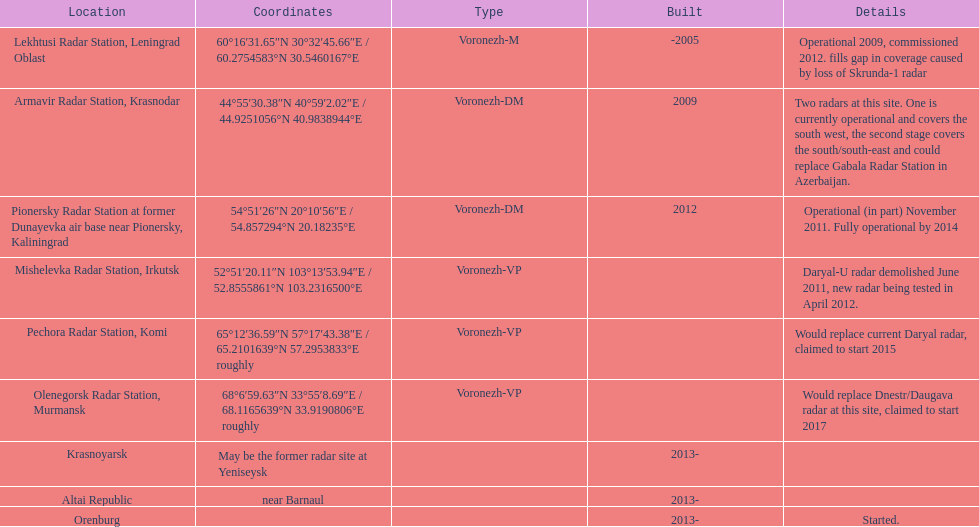What was the duration for the pionersky radar station to transition from partly functional to completely functional? 3 years. 